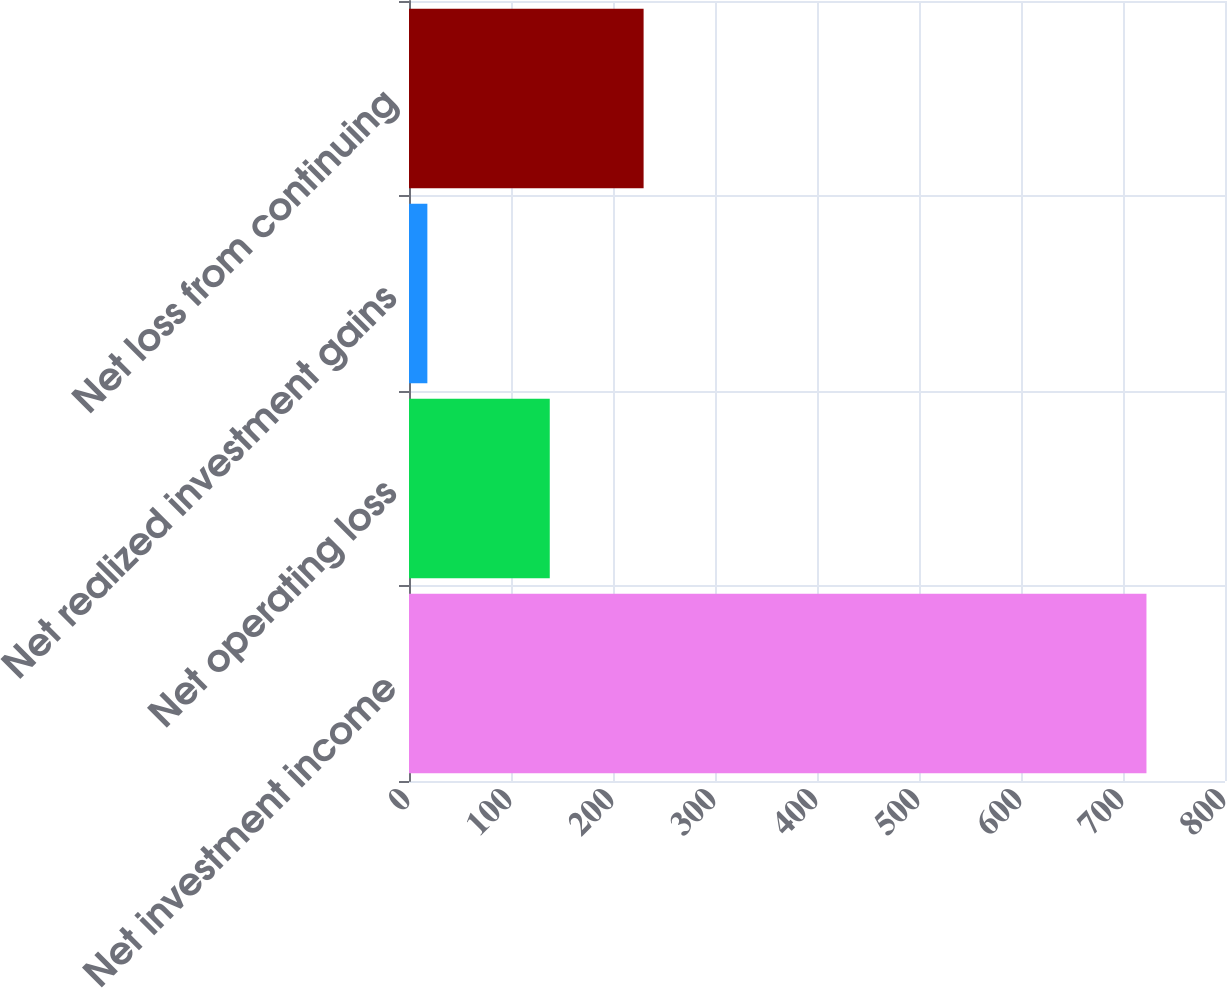<chart> <loc_0><loc_0><loc_500><loc_500><bar_chart><fcel>Net investment income<fcel>Net operating loss<fcel>Net realized investment gains<fcel>Net loss from continuing<nl><fcel>723<fcel>138<fcel>18<fcel>230<nl></chart> 